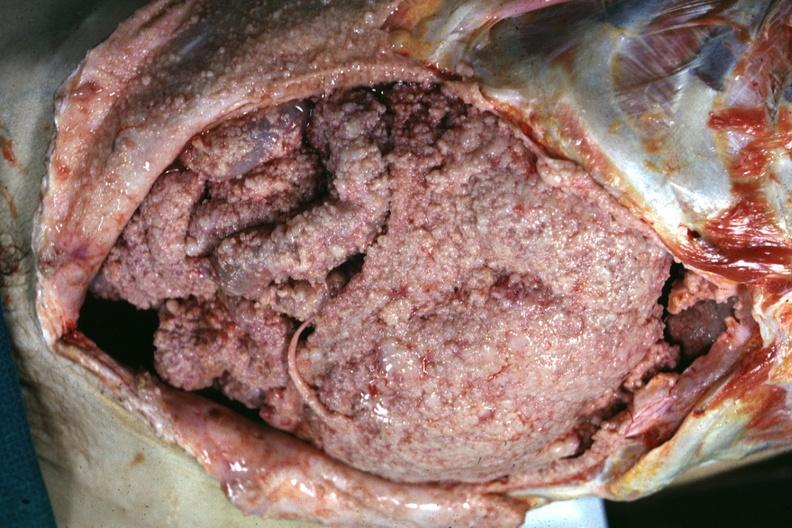does leiomyosarcoma show opened abdomen showing tumor everywhere this also could be peritoneal carcinomatosis it looks the same?
Answer the question using a single word or phrase. No 